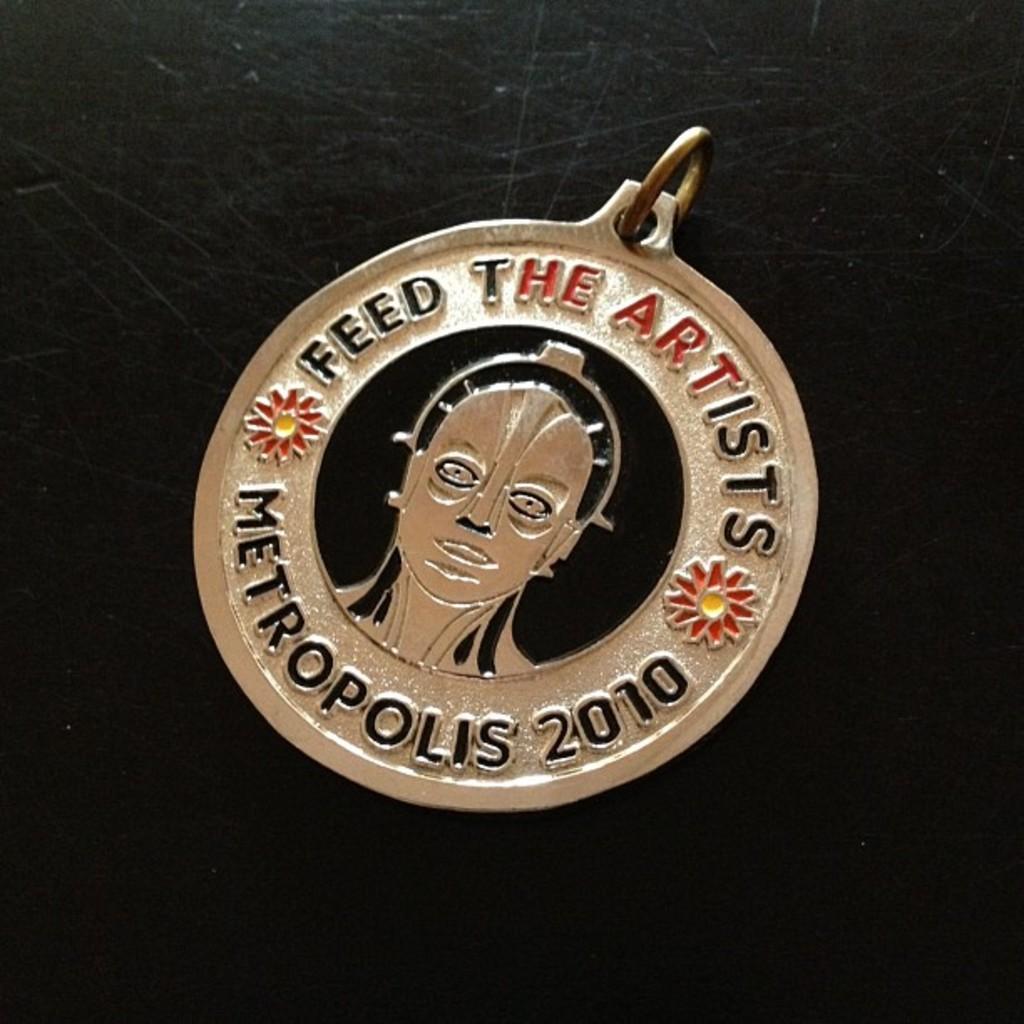Can you describe this image briefly? This image consists of a locket made up of metal. It is kept on a table which is in black color. 